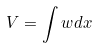Convert formula to latex. <formula><loc_0><loc_0><loc_500><loc_500>V = \int w d x</formula> 